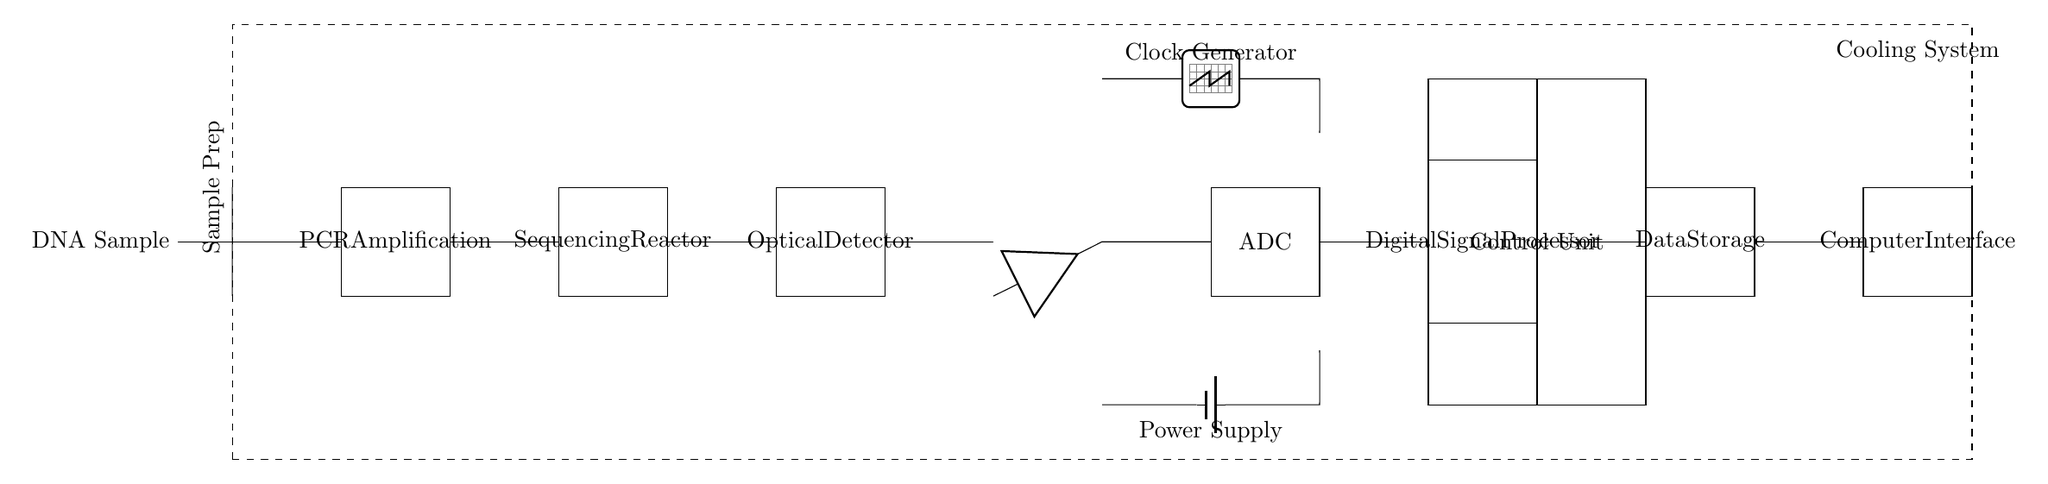what is the first component in the circuit? The first component in the circuit is the "DNA Sample" input, which is located at the leftmost side.
Answer: DNA Sample what is the purpose of the PCR Amplification block? The PCR Amplification block is used to amplify the DNA sample, which is crucial for increasing the amount of DNA available for sequencing.
Answer: Amplification how many major stages are there in this circuit diagram? There are six major stages in this circuit: Sample Prep, PCR Amplification, Sequencing Reactor, Optical Detector, ADC, and Digital Signal Processor.
Answer: Six what does ADC stand for in this circuit? ADC stands for Analog-to-Digital Converter, which converts the amplified analog signals into digital form for further processing.
Answer: Analog-to-Digital Converter which component supplies power to the circuit? The Power Supply component is responsible for providing power to the circuit, shown connected to the signal path at the bottom.
Answer: Power Supply what role does the Clock Generator play in this circuit? The Clock Generator provides timing signals that synchronize operations within the circuit to ensure coordination among components.
Answer: Timing signals 